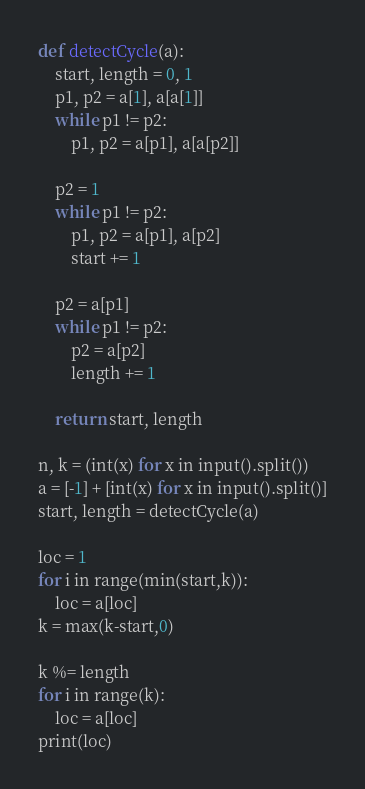<code> <loc_0><loc_0><loc_500><loc_500><_Python_>def detectCycle(a):
    start, length = 0, 1
    p1, p2 = a[1], a[a[1]]
    while p1 != p2:
        p1, p2 = a[p1], a[a[p2]]
    
    p2 = 1
    while p1 != p2:
        p1, p2 = a[p1], a[p2]
        start += 1
    
    p2 = a[p1]
    while p1 != p2:
        p2 = a[p2]
        length += 1
    
    return start, length

n, k = (int(x) for x in input().split())
a = [-1] + [int(x) for x in input().split()]
start, length = detectCycle(a)

loc = 1
for i in range(min(start,k)):
    loc = a[loc]
k = max(k-start,0)

k %= length
for i in range(k):
    loc = a[loc]
print(loc)</code> 